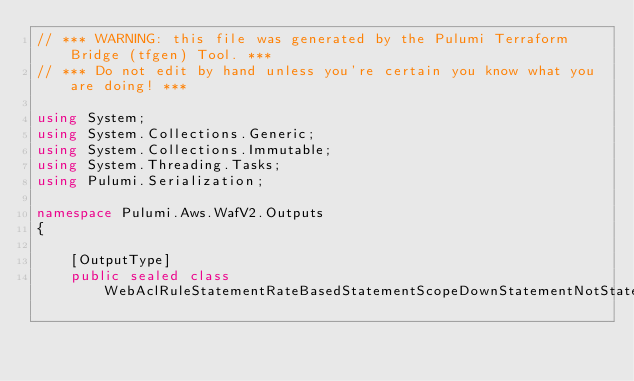<code> <loc_0><loc_0><loc_500><loc_500><_C#_>// *** WARNING: this file was generated by the Pulumi Terraform Bridge (tfgen) Tool. ***
// *** Do not edit by hand unless you're certain you know what you are doing! ***

using System;
using System.Collections.Generic;
using System.Collections.Immutable;
using System.Threading.Tasks;
using Pulumi.Serialization;

namespace Pulumi.Aws.WafV2.Outputs
{

    [OutputType]
    public sealed class WebAclRuleStatementRateBasedStatementScopeDownStatementNotStatementStatementXssMatchStatementFieldToMatchSingleQueryArgument</code> 